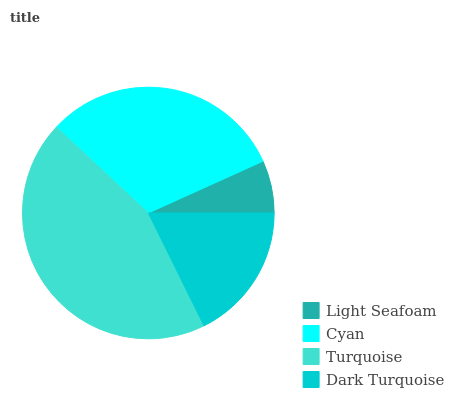Is Light Seafoam the minimum?
Answer yes or no. Yes. Is Turquoise the maximum?
Answer yes or no. Yes. Is Cyan the minimum?
Answer yes or no. No. Is Cyan the maximum?
Answer yes or no. No. Is Cyan greater than Light Seafoam?
Answer yes or no. Yes. Is Light Seafoam less than Cyan?
Answer yes or no. Yes. Is Light Seafoam greater than Cyan?
Answer yes or no. No. Is Cyan less than Light Seafoam?
Answer yes or no. No. Is Cyan the high median?
Answer yes or no. Yes. Is Dark Turquoise the low median?
Answer yes or no. Yes. Is Turquoise the high median?
Answer yes or no. No. Is Turquoise the low median?
Answer yes or no. No. 